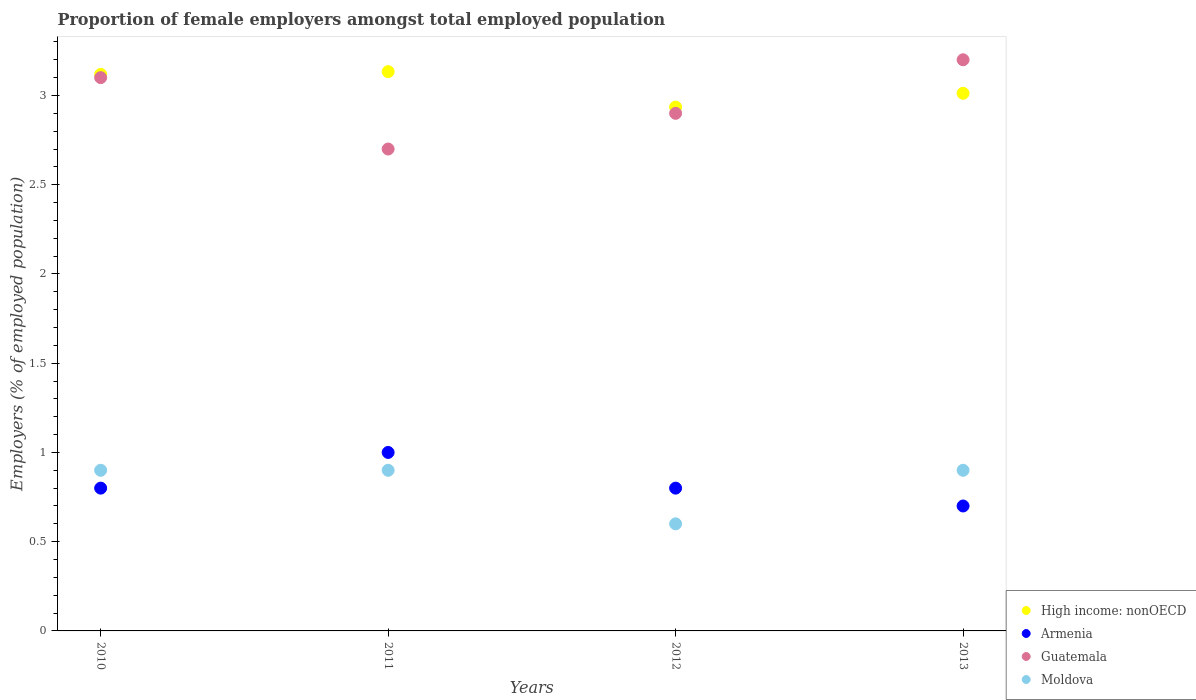What is the proportion of female employers in Armenia in 2013?
Offer a very short reply. 0.7. Across all years, what is the maximum proportion of female employers in Guatemala?
Offer a terse response. 3.2. Across all years, what is the minimum proportion of female employers in Guatemala?
Offer a terse response. 2.7. In which year was the proportion of female employers in Armenia minimum?
Your response must be concise. 2013. What is the total proportion of female employers in Moldova in the graph?
Provide a succinct answer. 3.3. What is the difference between the proportion of female employers in Armenia in 2012 and that in 2013?
Give a very brief answer. 0.1. What is the difference between the proportion of female employers in Moldova in 2011 and the proportion of female employers in Guatemala in 2010?
Offer a very short reply. -2.2. What is the average proportion of female employers in High income: nonOECD per year?
Give a very brief answer. 3.05. In the year 2012, what is the difference between the proportion of female employers in Guatemala and proportion of female employers in Moldova?
Provide a short and direct response. 2.3. In how many years, is the proportion of female employers in Moldova greater than 1.5 %?
Provide a succinct answer. 0. What is the ratio of the proportion of female employers in High income: nonOECD in 2012 to that in 2013?
Provide a short and direct response. 0.97. Is the difference between the proportion of female employers in Guatemala in 2011 and 2012 greater than the difference between the proportion of female employers in Moldova in 2011 and 2012?
Give a very brief answer. No. What is the difference between the highest and the second highest proportion of female employers in High income: nonOECD?
Your answer should be compact. 0.02. What is the difference between the highest and the lowest proportion of female employers in Armenia?
Give a very brief answer. 0.3. In how many years, is the proportion of female employers in Moldova greater than the average proportion of female employers in Moldova taken over all years?
Offer a terse response. 3. Is the proportion of female employers in Armenia strictly greater than the proportion of female employers in Guatemala over the years?
Provide a succinct answer. No. How many dotlines are there?
Your response must be concise. 4. How many years are there in the graph?
Provide a short and direct response. 4. What is the difference between two consecutive major ticks on the Y-axis?
Ensure brevity in your answer.  0.5. Are the values on the major ticks of Y-axis written in scientific E-notation?
Ensure brevity in your answer.  No. How many legend labels are there?
Provide a short and direct response. 4. How are the legend labels stacked?
Your response must be concise. Vertical. What is the title of the graph?
Your answer should be compact. Proportion of female employers amongst total employed population. What is the label or title of the Y-axis?
Offer a terse response. Employers (% of employed population). What is the Employers (% of employed population) in High income: nonOECD in 2010?
Your answer should be very brief. 3.12. What is the Employers (% of employed population) of Armenia in 2010?
Ensure brevity in your answer.  0.8. What is the Employers (% of employed population) in Guatemala in 2010?
Keep it short and to the point. 3.1. What is the Employers (% of employed population) in Moldova in 2010?
Your answer should be very brief. 0.9. What is the Employers (% of employed population) in High income: nonOECD in 2011?
Offer a very short reply. 3.13. What is the Employers (% of employed population) of Guatemala in 2011?
Your answer should be very brief. 2.7. What is the Employers (% of employed population) of Moldova in 2011?
Provide a succinct answer. 0.9. What is the Employers (% of employed population) in High income: nonOECD in 2012?
Provide a succinct answer. 2.94. What is the Employers (% of employed population) of Armenia in 2012?
Keep it short and to the point. 0.8. What is the Employers (% of employed population) in Guatemala in 2012?
Offer a terse response. 2.9. What is the Employers (% of employed population) in Moldova in 2012?
Offer a terse response. 0.6. What is the Employers (% of employed population) of High income: nonOECD in 2013?
Make the answer very short. 3.01. What is the Employers (% of employed population) in Armenia in 2013?
Offer a very short reply. 0.7. What is the Employers (% of employed population) in Guatemala in 2013?
Your response must be concise. 3.2. What is the Employers (% of employed population) of Moldova in 2013?
Offer a very short reply. 0.9. Across all years, what is the maximum Employers (% of employed population) of High income: nonOECD?
Give a very brief answer. 3.13. Across all years, what is the maximum Employers (% of employed population) of Guatemala?
Give a very brief answer. 3.2. Across all years, what is the maximum Employers (% of employed population) of Moldova?
Your answer should be compact. 0.9. Across all years, what is the minimum Employers (% of employed population) in High income: nonOECD?
Your response must be concise. 2.94. Across all years, what is the minimum Employers (% of employed population) in Armenia?
Your response must be concise. 0.7. Across all years, what is the minimum Employers (% of employed population) in Guatemala?
Your answer should be very brief. 2.7. Across all years, what is the minimum Employers (% of employed population) in Moldova?
Provide a short and direct response. 0.6. What is the total Employers (% of employed population) of High income: nonOECD in the graph?
Offer a terse response. 12.2. What is the total Employers (% of employed population) in Guatemala in the graph?
Ensure brevity in your answer.  11.9. What is the difference between the Employers (% of employed population) in High income: nonOECD in 2010 and that in 2011?
Provide a short and direct response. -0.02. What is the difference between the Employers (% of employed population) in Guatemala in 2010 and that in 2011?
Give a very brief answer. 0.4. What is the difference between the Employers (% of employed population) in High income: nonOECD in 2010 and that in 2012?
Provide a succinct answer. 0.18. What is the difference between the Employers (% of employed population) in Armenia in 2010 and that in 2012?
Your response must be concise. 0. What is the difference between the Employers (% of employed population) of Moldova in 2010 and that in 2012?
Offer a terse response. 0.3. What is the difference between the Employers (% of employed population) in High income: nonOECD in 2010 and that in 2013?
Offer a very short reply. 0.11. What is the difference between the Employers (% of employed population) in Armenia in 2010 and that in 2013?
Make the answer very short. 0.1. What is the difference between the Employers (% of employed population) of Moldova in 2010 and that in 2013?
Offer a very short reply. 0. What is the difference between the Employers (% of employed population) in High income: nonOECD in 2011 and that in 2012?
Your answer should be very brief. 0.2. What is the difference between the Employers (% of employed population) in Armenia in 2011 and that in 2012?
Offer a terse response. 0.2. What is the difference between the Employers (% of employed population) in Moldova in 2011 and that in 2012?
Give a very brief answer. 0.3. What is the difference between the Employers (% of employed population) in High income: nonOECD in 2011 and that in 2013?
Your answer should be very brief. 0.12. What is the difference between the Employers (% of employed population) in Armenia in 2011 and that in 2013?
Your response must be concise. 0.3. What is the difference between the Employers (% of employed population) of Guatemala in 2011 and that in 2013?
Give a very brief answer. -0.5. What is the difference between the Employers (% of employed population) of High income: nonOECD in 2012 and that in 2013?
Offer a terse response. -0.08. What is the difference between the Employers (% of employed population) in Armenia in 2012 and that in 2013?
Offer a very short reply. 0.1. What is the difference between the Employers (% of employed population) of Guatemala in 2012 and that in 2013?
Ensure brevity in your answer.  -0.3. What is the difference between the Employers (% of employed population) in Moldova in 2012 and that in 2013?
Keep it short and to the point. -0.3. What is the difference between the Employers (% of employed population) of High income: nonOECD in 2010 and the Employers (% of employed population) of Armenia in 2011?
Provide a short and direct response. 2.12. What is the difference between the Employers (% of employed population) in High income: nonOECD in 2010 and the Employers (% of employed population) in Guatemala in 2011?
Your answer should be very brief. 0.42. What is the difference between the Employers (% of employed population) in High income: nonOECD in 2010 and the Employers (% of employed population) in Moldova in 2011?
Give a very brief answer. 2.22. What is the difference between the Employers (% of employed population) of Armenia in 2010 and the Employers (% of employed population) of Guatemala in 2011?
Provide a succinct answer. -1.9. What is the difference between the Employers (% of employed population) of Armenia in 2010 and the Employers (% of employed population) of Moldova in 2011?
Offer a very short reply. -0.1. What is the difference between the Employers (% of employed population) in High income: nonOECD in 2010 and the Employers (% of employed population) in Armenia in 2012?
Give a very brief answer. 2.32. What is the difference between the Employers (% of employed population) in High income: nonOECD in 2010 and the Employers (% of employed population) in Guatemala in 2012?
Give a very brief answer. 0.22. What is the difference between the Employers (% of employed population) in High income: nonOECD in 2010 and the Employers (% of employed population) in Moldova in 2012?
Ensure brevity in your answer.  2.52. What is the difference between the Employers (% of employed population) of Armenia in 2010 and the Employers (% of employed population) of Moldova in 2012?
Ensure brevity in your answer.  0.2. What is the difference between the Employers (% of employed population) of High income: nonOECD in 2010 and the Employers (% of employed population) of Armenia in 2013?
Your answer should be very brief. 2.42. What is the difference between the Employers (% of employed population) of High income: nonOECD in 2010 and the Employers (% of employed population) of Guatemala in 2013?
Ensure brevity in your answer.  -0.08. What is the difference between the Employers (% of employed population) in High income: nonOECD in 2010 and the Employers (% of employed population) in Moldova in 2013?
Your answer should be compact. 2.22. What is the difference between the Employers (% of employed population) in Armenia in 2010 and the Employers (% of employed population) in Moldova in 2013?
Keep it short and to the point. -0.1. What is the difference between the Employers (% of employed population) of High income: nonOECD in 2011 and the Employers (% of employed population) of Armenia in 2012?
Give a very brief answer. 2.33. What is the difference between the Employers (% of employed population) of High income: nonOECD in 2011 and the Employers (% of employed population) of Guatemala in 2012?
Offer a very short reply. 0.23. What is the difference between the Employers (% of employed population) of High income: nonOECD in 2011 and the Employers (% of employed population) of Moldova in 2012?
Your response must be concise. 2.53. What is the difference between the Employers (% of employed population) of Armenia in 2011 and the Employers (% of employed population) of Moldova in 2012?
Your response must be concise. 0.4. What is the difference between the Employers (% of employed population) of High income: nonOECD in 2011 and the Employers (% of employed population) of Armenia in 2013?
Provide a succinct answer. 2.43. What is the difference between the Employers (% of employed population) in High income: nonOECD in 2011 and the Employers (% of employed population) in Guatemala in 2013?
Provide a short and direct response. -0.07. What is the difference between the Employers (% of employed population) in High income: nonOECD in 2011 and the Employers (% of employed population) in Moldova in 2013?
Offer a very short reply. 2.23. What is the difference between the Employers (% of employed population) of Armenia in 2011 and the Employers (% of employed population) of Moldova in 2013?
Keep it short and to the point. 0.1. What is the difference between the Employers (% of employed population) in High income: nonOECD in 2012 and the Employers (% of employed population) in Armenia in 2013?
Provide a short and direct response. 2.23. What is the difference between the Employers (% of employed population) in High income: nonOECD in 2012 and the Employers (% of employed population) in Guatemala in 2013?
Your response must be concise. -0.27. What is the difference between the Employers (% of employed population) of High income: nonOECD in 2012 and the Employers (% of employed population) of Moldova in 2013?
Provide a short and direct response. 2.04. What is the average Employers (% of employed population) in High income: nonOECD per year?
Your answer should be very brief. 3.05. What is the average Employers (% of employed population) in Armenia per year?
Your answer should be very brief. 0.82. What is the average Employers (% of employed population) of Guatemala per year?
Give a very brief answer. 2.98. What is the average Employers (% of employed population) in Moldova per year?
Ensure brevity in your answer.  0.82. In the year 2010, what is the difference between the Employers (% of employed population) of High income: nonOECD and Employers (% of employed population) of Armenia?
Offer a very short reply. 2.32. In the year 2010, what is the difference between the Employers (% of employed population) in High income: nonOECD and Employers (% of employed population) in Guatemala?
Keep it short and to the point. 0.02. In the year 2010, what is the difference between the Employers (% of employed population) in High income: nonOECD and Employers (% of employed population) in Moldova?
Provide a succinct answer. 2.22. In the year 2010, what is the difference between the Employers (% of employed population) in Armenia and Employers (% of employed population) in Moldova?
Keep it short and to the point. -0.1. In the year 2010, what is the difference between the Employers (% of employed population) in Guatemala and Employers (% of employed population) in Moldova?
Your response must be concise. 2.2. In the year 2011, what is the difference between the Employers (% of employed population) of High income: nonOECD and Employers (% of employed population) of Armenia?
Make the answer very short. 2.13. In the year 2011, what is the difference between the Employers (% of employed population) of High income: nonOECD and Employers (% of employed population) of Guatemala?
Provide a short and direct response. 0.43. In the year 2011, what is the difference between the Employers (% of employed population) of High income: nonOECD and Employers (% of employed population) of Moldova?
Provide a succinct answer. 2.23. In the year 2011, what is the difference between the Employers (% of employed population) in Armenia and Employers (% of employed population) in Guatemala?
Your answer should be compact. -1.7. In the year 2011, what is the difference between the Employers (% of employed population) in Guatemala and Employers (% of employed population) in Moldova?
Make the answer very short. 1.8. In the year 2012, what is the difference between the Employers (% of employed population) of High income: nonOECD and Employers (% of employed population) of Armenia?
Provide a succinct answer. 2.13. In the year 2012, what is the difference between the Employers (% of employed population) in High income: nonOECD and Employers (% of employed population) in Guatemala?
Give a very brief answer. 0.04. In the year 2012, what is the difference between the Employers (% of employed population) in High income: nonOECD and Employers (% of employed population) in Moldova?
Keep it short and to the point. 2.33. In the year 2012, what is the difference between the Employers (% of employed population) of Armenia and Employers (% of employed population) of Guatemala?
Ensure brevity in your answer.  -2.1. In the year 2012, what is the difference between the Employers (% of employed population) in Guatemala and Employers (% of employed population) in Moldova?
Provide a short and direct response. 2.3. In the year 2013, what is the difference between the Employers (% of employed population) of High income: nonOECD and Employers (% of employed population) of Armenia?
Your answer should be compact. 2.31. In the year 2013, what is the difference between the Employers (% of employed population) in High income: nonOECD and Employers (% of employed population) in Guatemala?
Provide a succinct answer. -0.19. In the year 2013, what is the difference between the Employers (% of employed population) in High income: nonOECD and Employers (% of employed population) in Moldova?
Provide a short and direct response. 2.11. What is the ratio of the Employers (% of employed population) in High income: nonOECD in 2010 to that in 2011?
Keep it short and to the point. 1. What is the ratio of the Employers (% of employed population) of Guatemala in 2010 to that in 2011?
Provide a succinct answer. 1.15. What is the ratio of the Employers (% of employed population) of Moldova in 2010 to that in 2011?
Provide a short and direct response. 1. What is the ratio of the Employers (% of employed population) of High income: nonOECD in 2010 to that in 2012?
Offer a terse response. 1.06. What is the ratio of the Employers (% of employed population) in Guatemala in 2010 to that in 2012?
Offer a very short reply. 1.07. What is the ratio of the Employers (% of employed population) in High income: nonOECD in 2010 to that in 2013?
Offer a very short reply. 1.04. What is the ratio of the Employers (% of employed population) in Guatemala in 2010 to that in 2013?
Ensure brevity in your answer.  0.97. What is the ratio of the Employers (% of employed population) in Moldova in 2010 to that in 2013?
Make the answer very short. 1. What is the ratio of the Employers (% of employed population) of High income: nonOECD in 2011 to that in 2012?
Your response must be concise. 1.07. What is the ratio of the Employers (% of employed population) of Armenia in 2011 to that in 2012?
Your answer should be compact. 1.25. What is the ratio of the Employers (% of employed population) in Guatemala in 2011 to that in 2012?
Your answer should be very brief. 0.93. What is the ratio of the Employers (% of employed population) in High income: nonOECD in 2011 to that in 2013?
Provide a succinct answer. 1.04. What is the ratio of the Employers (% of employed population) in Armenia in 2011 to that in 2013?
Your answer should be very brief. 1.43. What is the ratio of the Employers (% of employed population) of Guatemala in 2011 to that in 2013?
Your answer should be very brief. 0.84. What is the ratio of the Employers (% of employed population) of Moldova in 2011 to that in 2013?
Offer a terse response. 1. What is the ratio of the Employers (% of employed population) of High income: nonOECD in 2012 to that in 2013?
Give a very brief answer. 0.97. What is the ratio of the Employers (% of employed population) of Armenia in 2012 to that in 2013?
Offer a terse response. 1.14. What is the ratio of the Employers (% of employed population) in Guatemala in 2012 to that in 2013?
Keep it short and to the point. 0.91. What is the difference between the highest and the second highest Employers (% of employed population) of High income: nonOECD?
Give a very brief answer. 0.02. What is the difference between the highest and the second highest Employers (% of employed population) in Armenia?
Provide a succinct answer. 0.2. What is the difference between the highest and the second highest Employers (% of employed population) in Guatemala?
Your answer should be very brief. 0.1. What is the difference between the highest and the lowest Employers (% of employed population) of High income: nonOECD?
Make the answer very short. 0.2. What is the difference between the highest and the lowest Employers (% of employed population) in Armenia?
Keep it short and to the point. 0.3. What is the difference between the highest and the lowest Employers (% of employed population) of Guatemala?
Your response must be concise. 0.5. What is the difference between the highest and the lowest Employers (% of employed population) of Moldova?
Provide a succinct answer. 0.3. 